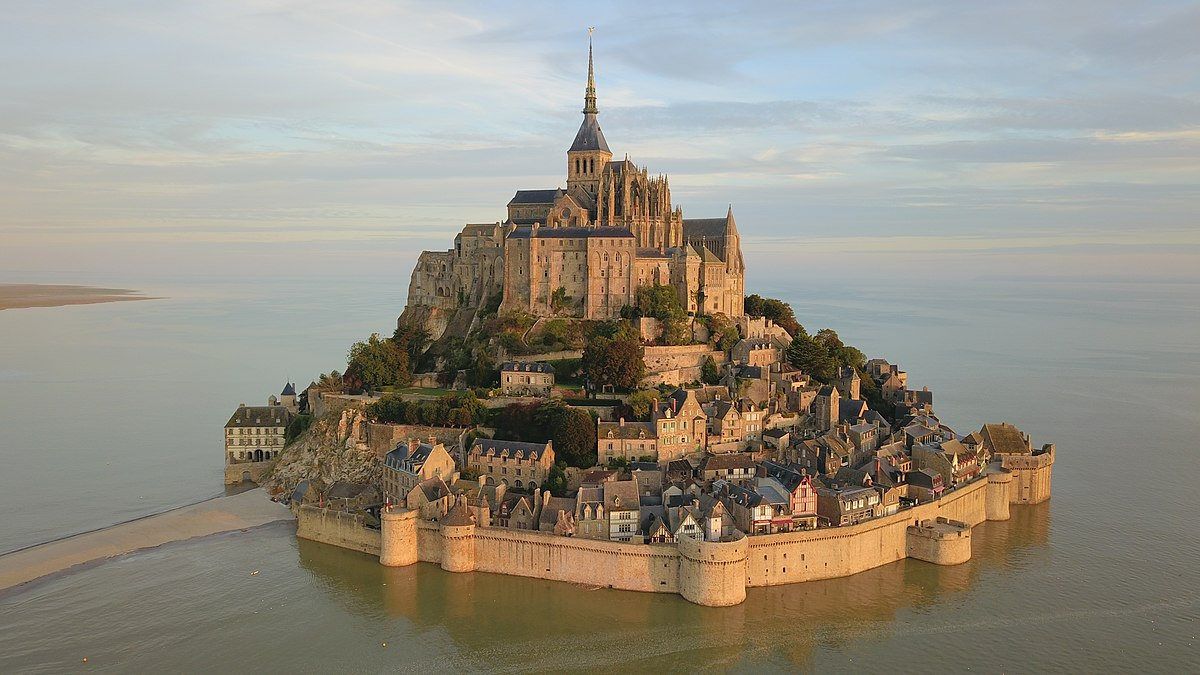Never-ending stairs and secret chambers, does Mont St Michel have any? Indeed, Mont St Michel is replete with never-ending stairs and secret chambers, which add to its mystical allure. The Grand Degré is one of the most notable staircases, a steep and narrow ascent that has tested the endurance of countless pilgrims over the centuries. Within the abbey, you will find a labyrinth of passages and hidden rooms, some of which were used by monks for meditation and solitude. The cloisters provide a serene place for reflection, yet the surrounding narrow corridors can lead to unexpected nooks and crannies, each with its own story. Below the abbey, there are also dungeons and storehouses that were vital during sieges, discreetly tucked away yet integral to the fortress's resilience. The intricate design of these staircases and chambers not only speaks to the island's defensive ingenuity but also encapsulates the medieval spirit of mystery and mysticism, inviting those who visit to lose themselves in its ancient embrace. 